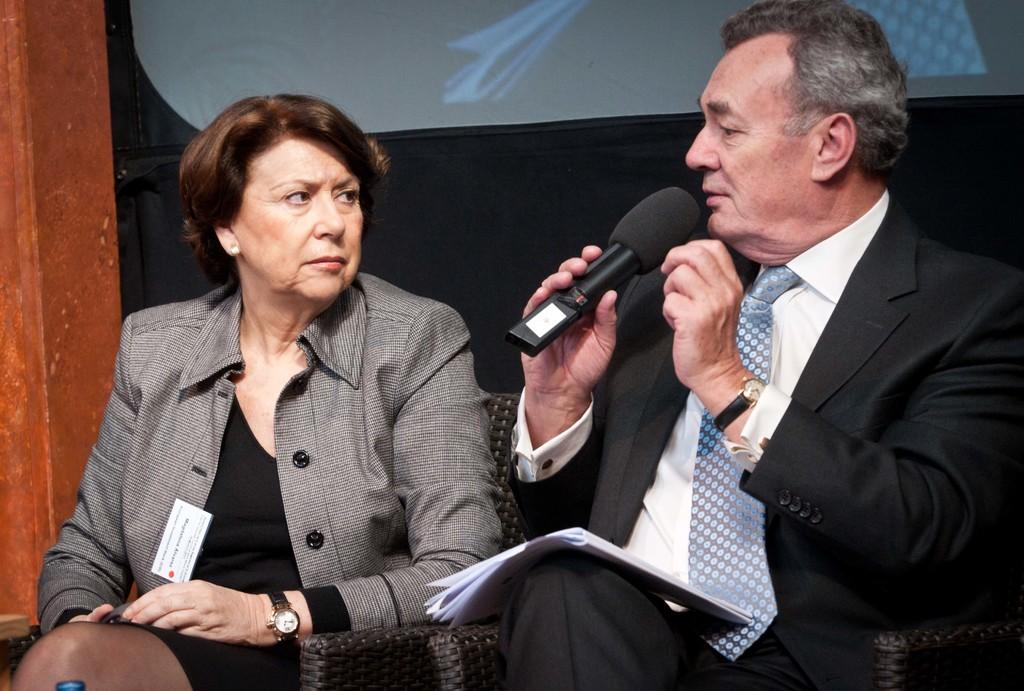Who are the people in the image? There is a woman and a man in the image. What are the positions of the woman and the man in the image? Both the woman and the man are sitting on chairs. What is the man holding in his hand? The man is holding a microphone in his hand. What type of butter can be seen on the woman's knee in the image? There is no butter present in the image, nor is there any indication of the woman's knee being visible. 